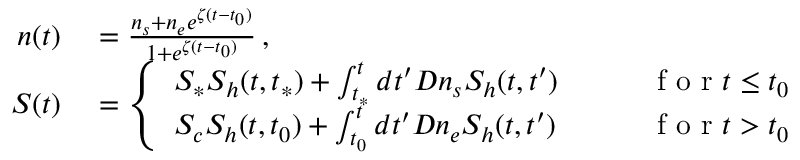<formula> <loc_0><loc_0><loc_500><loc_500>\begin{array} { r l r } { n ( t ) } & = \frac { n _ { s } + n _ { e } e ^ { \zeta ( t - t _ { 0 } ) } } { 1 + e ^ { \zeta ( t - t _ { 0 } ) } } \, , } \\ { S ( t ) } & = \left \{ \begin{array} { l l } { S _ { * } S _ { h } ( t , t _ { * } ) + \int _ { t _ { * } } ^ { t } d t ^ { \prime } D n _ { s } S _ { h } ( t , t ^ { \prime } ) \quad } & { f o r t \leq t _ { 0 } } \\ { S _ { c } S _ { h } ( t , t _ { 0 } ) + \int _ { t _ { 0 } } ^ { t } d t ^ { \prime } D n _ { e } S _ { h } ( t , t ^ { \prime } ) \quad } & { f o r t > t _ { 0 } } \end{array} } \end{array}</formula> 